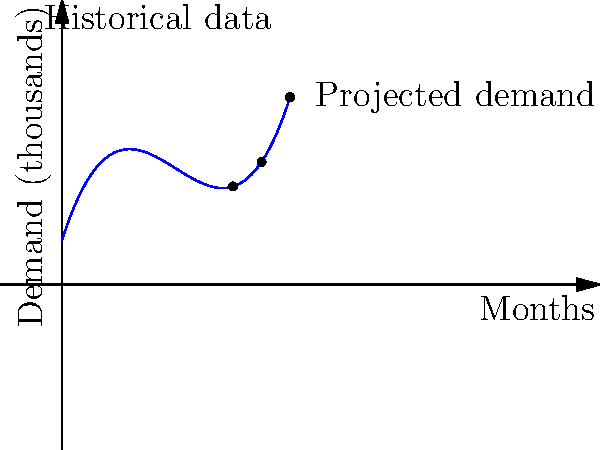As a flower grower, you've been tracking the monthly demand for your products over the past 6 months. Your digital marketer has used polynomial regression to create a model for predicting future demand. The graph shows the historical data and projected demand for the next two months. Based on the polynomial model, what is the approximate projected demand (in thousands) for your flowers in the 8th month? To solve this problem, we need to follow these steps:

1. Understand that the graph represents a polynomial regression model based on historical data.
2. Identify that the x-axis represents months and the y-axis represents demand in thousands.
3. Locate the point on the curve corresponding to the 8th month (x = 8).
4. Estimate the y-value (demand) for x = 8 by looking at the corresponding point on the curve.

The curve appears to be a cubic polynomial (degree 3), which fits the historical data and extends to predict future demand. For the 8th month:

1. Find x = 8 on the x-axis.
2. Move vertically from x = 8 to the curve.
3. From the point on the curve, move horizontally to the y-axis.
4. The y-value at this point represents the projected demand for the 8th month.

By visual estimation, the demand for the 8th month appears to be approximately 70 thousand units.
Answer: Approximately 70 thousand 